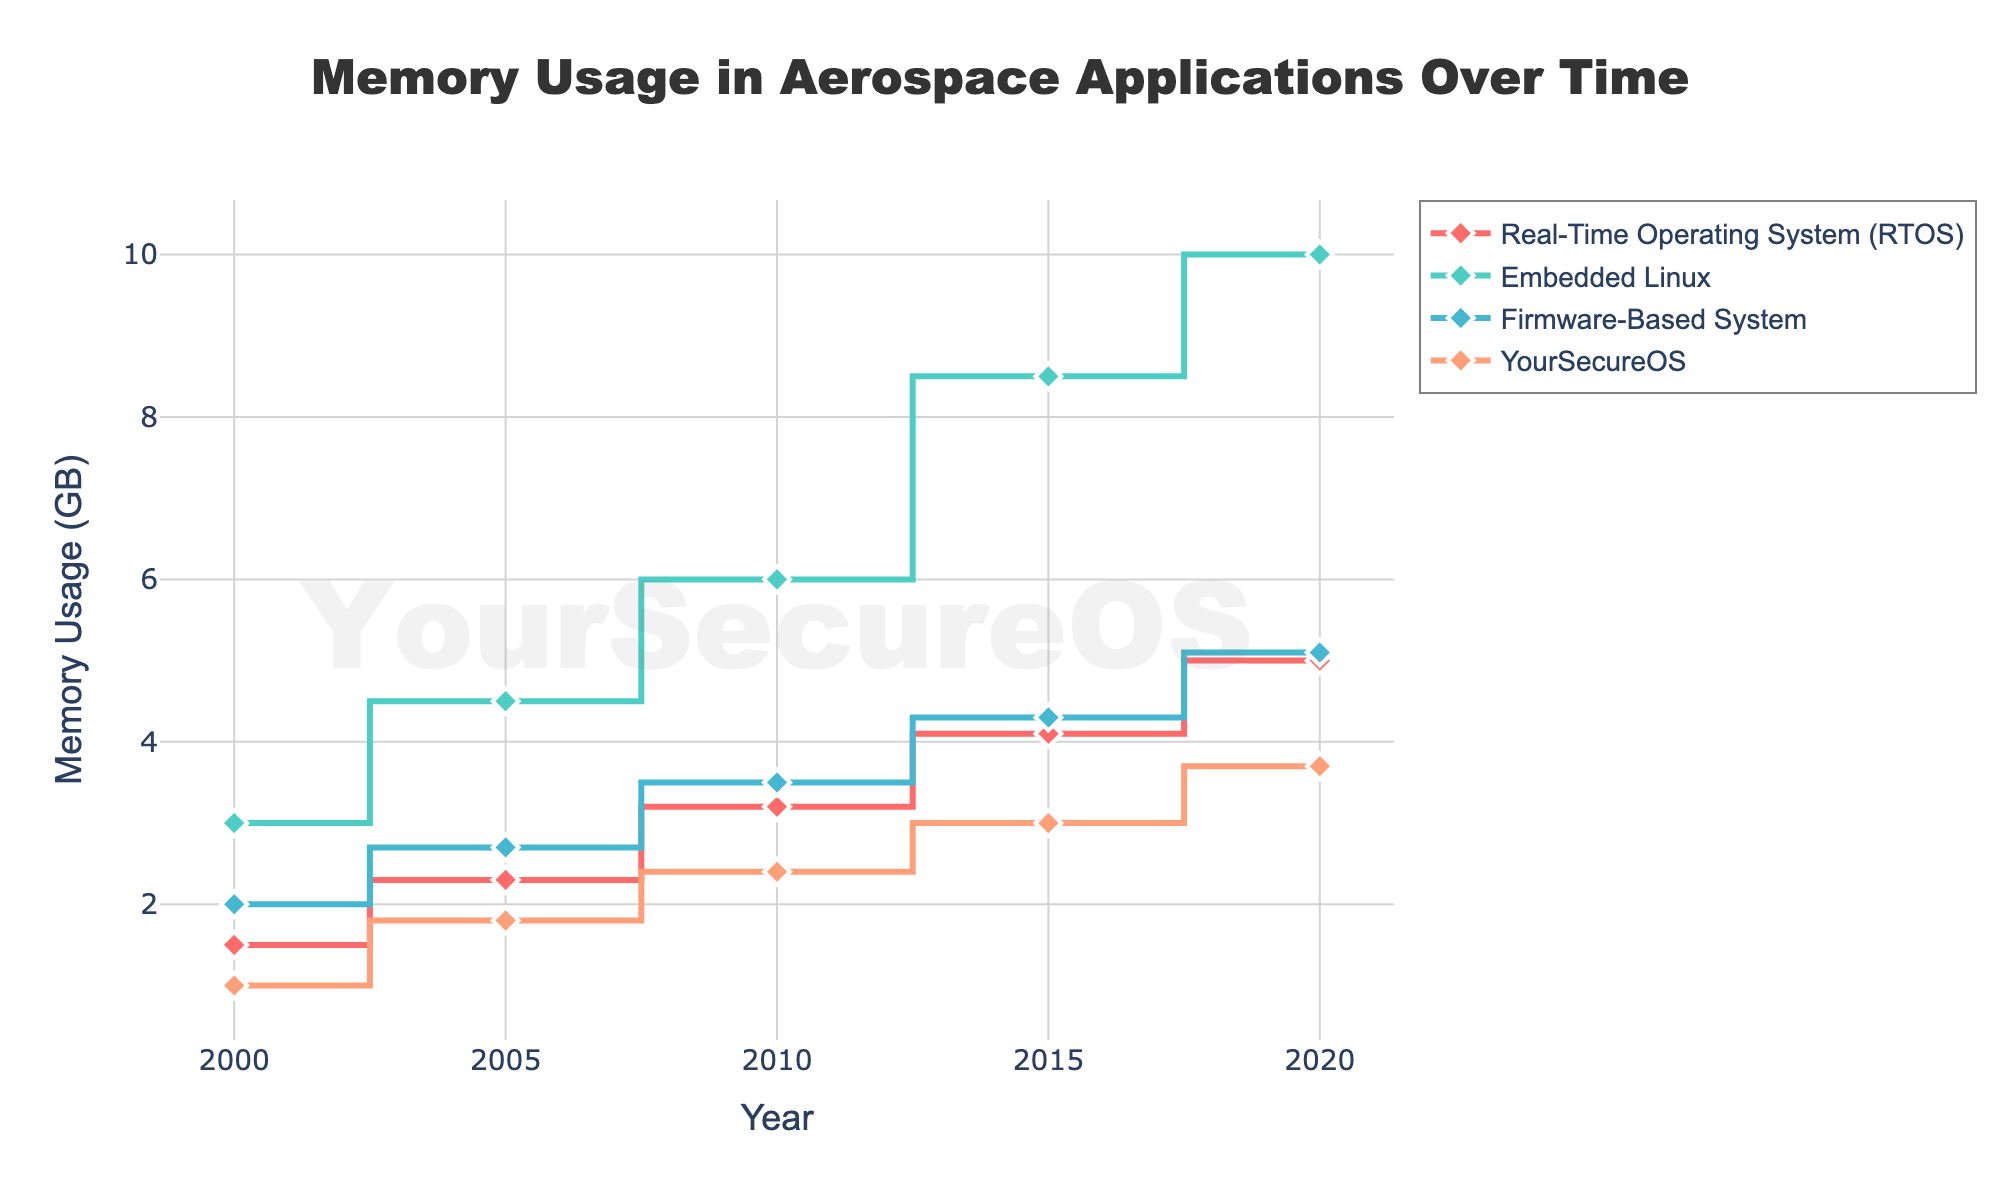What is the title of the stair plot? The title of the plot is typically found at the top center. In this case, it reads "Memory Usage in Aerospace Applications Over Time."
Answer: Memory Usage in Aerospace Applications Over Time What is the y-axis title and what does it measure? The y-axis title is found along the y-axis of the plot. Here, it states "Memory Usage (GB)," indicating the plot measures memory usage in gigabytes.
Answer: Memory Usage (GB) How does the memory usage of Embedded Linux in 2000 compare to 2020? Locate the value for Embedded Linux in 2000 and 2020 on the plot. In 2000, it's 3.0 GB, and in 2020, it's 10.0 GB. Subtract to find the increase: 10.0 - 3.0 = 7.0 GB.
Answer: 7.0 GB increase Which operating system had the lowest memory usage in 2015? Look at the data points for the year 2015 across all operating systems. YourSecureOS has the lowest value at 3.0 GB.
Answer: YourSecureOS Did any operating system show a linear increase in memory usage over the years? A linear increase would mean constant increments. By examining the traces, especially their slopes, the Real-Time Operating System (RTOS) shows a relatively linear increase.
Answer: Real-Time Operating System (RTOS) What was the total memory usage for all operating systems combined in 2010? Find and sum the memory usage values for all operating systems in 2010: 3.2 (RTOS) + 6.0 (Embedded Linux) + 3.5 (Firmware-Based System) + 2.4 (YourSecureOS) = 15.1 GB.
Answer: 15.1 GB Between which years did the Firmware-Based System see the highest increase in memory usage? Compare the differences in memory usage for adjacent years for the Firmware-Based System. The largest increase is from 2010 to 2015, rising from 3.5 to 4.3 GB, an increase of 0.8 GB.
Answer: 2010 to 2015 Which year had the greatest variation in memory usage among the operating systems? Calculate the range (max - min) of memory usage for each year. The year 2020 has the largest range: 10.0 (Embedded Linux) - 3.7 (YourSecureOS) = 6.3 GB.
Answer: 2020 What is the average memory usage of YourSecureOS from 2000 to 2020? Sum the memory usage values for each year and divide by the number of data points: (1.0 + 1.8 + 2.4 + 3.0 + 3.7) / 5 = 11.9 / 5 = 2.38 GB.
Answer: 2.38 GB What can you infer about the trend in memory usage for all operating systems over time? By observing all data points and their trends, it is evident that memory usage for all operating systems has consistently increased from 2000 to 2020.
Answer: Consistent Increase 